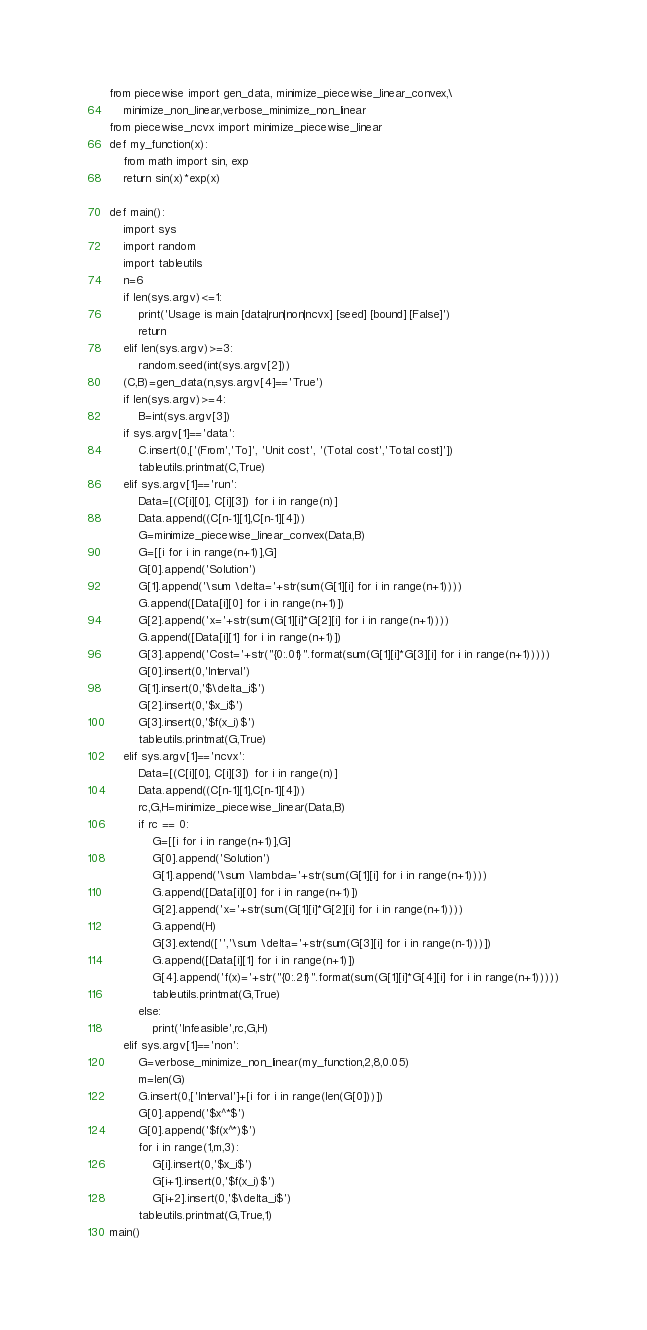<code> <loc_0><loc_0><loc_500><loc_500><_Python_>
from piecewise import gen_data, minimize_piecewise_linear_convex,\
    minimize_non_linear,verbose_minimize_non_linear
from piecewise_ncvx import minimize_piecewise_linear
def my_function(x):
    from math import sin, exp
    return sin(x)*exp(x)

def main():
    import sys
    import random
    import tableutils
    n=6
    if len(sys.argv)<=1:
        print('Usage is main [data|run|non|ncvx] [seed] [bound] [False]')
        return
    elif len(sys.argv)>=3:
        random.seed(int(sys.argv[2]))
    (C,B)=gen_data(n,sys.argv[4]=='True')
    if len(sys.argv)>=4:
        B=int(sys.argv[3])
    if sys.argv[1]=='data':
        C.insert(0,['(From','To]', 'Unit cost', '(Total cost','Total cost]'])        
        tableutils.printmat(C,True)
    elif sys.argv[1]=='run':
        Data=[(C[i][0], C[i][3]) for i in range(n)]
        Data.append((C[n-1][1],C[n-1][4]))
        G=minimize_piecewise_linear_convex(Data,B)
        G=[[i for i in range(n+1)],G]
        G[0].append('Solution')
        G[1].append('\sum \delta='+str(sum(G[1][i] for i in range(n+1))))
        G.append([Data[i][0] for i in range(n+1)])
        G[2].append('x='+str(sum(G[1][i]*G[2][i] for i in range(n+1))))
        G.append([Data[i][1] for i in range(n+1)])
        G[3].append('Cost='+str("{0:.0f}".format(sum(G[1][i]*G[3][i] for i in range(n+1)))))
        G[0].insert(0,'Interval')
        G[1].insert(0,'$\delta_i$')
        G[2].insert(0,'$x_i$')
        G[3].insert(0,'$f(x_i)$')
        tableutils.printmat(G,True)
    elif sys.argv[1]=='ncvx':
        Data=[(C[i][0], C[i][3]) for i in range(n)]
        Data.append((C[n-1][1],C[n-1][4]))
        rc,G,H=minimize_piecewise_linear(Data,B)
        if rc == 0:
            G=[[i for i in range(n+1)],G]
            G[0].append('Solution')
            G[1].append('\sum \lambda='+str(sum(G[1][i] for i in range(n+1))))
            G.append([Data[i][0] for i in range(n+1)])
            G[2].append('x='+str(sum(G[1][i]*G[2][i] for i in range(n+1))))
            G.append(H)
            G[3].extend(['','\sum \delta='+str(sum(G[3][i] for i in range(n-1)))])
            G.append([Data[i][1] for i in range(n+1)])
            G[4].append('f(x)='+str("{0:.2f}".format(sum(G[1][i]*G[4][i] for i in range(n+1)))))
            tableutils.printmat(G,True)
        else:
            print('Infeasible',rc,G,H)
    elif sys.argv[1]=='non':
        G=verbose_minimize_non_linear(my_function,2,8,0.05)
        m=len(G)
        G.insert(0,['Interval']+[i for i in range(len(G[0]))])
        G[0].append('$x^*$')
        G[0].append('$f(x^*)$')
        for i in range(1,m,3):
            G[i].insert(0,'$x_i$')
            G[i+1].insert(0,'$f(x_i)$')
            G[i+2].insert(0,'$\delta_i$')
        tableutils.printmat(G,True,1)
main()
</code> 